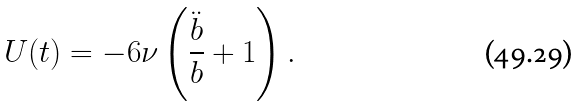<formula> <loc_0><loc_0><loc_500><loc_500>U ( t ) = - 6 \nu \left ( { \frac { \ddot { b } } b } + 1 \right ) .</formula> 